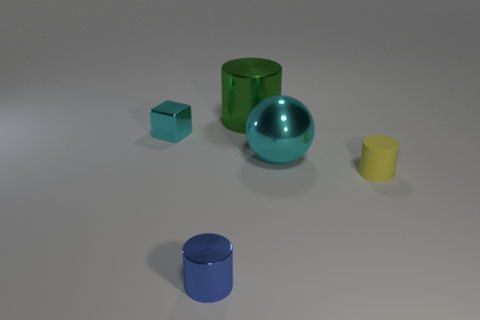There is a large object that is the same material as the large cylinder; what shape is it?
Offer a very short reply. Sphere. Is the number of cyan spheres to the left of the large cyan thing greater than the number of blue metallic cylinders?
Provide a short and direct response. No. How many tiny metal cubes have the same color as the big sphere?
Your answer should be very brief. 1. How many other things are the same color as the rubber cylinder?
Your answer should be compact. 0. Are there more metal objects than purple things?
Give a very brief answer. Yes. What is the material of the tiny yellow cylinder?
Offer a very short reply. Rubber. There is a metallic cylinder that is in front of the matte cylinder; is it the same size as the shiny sphere?
Make the answer very short. No. What size is the cyan shiny object that is on the right side of the blue cylinder?
Provide a succinct answer. Large. Is there anything else that has the same material as the tiny yellow object?
Your response must be concise. No. What number of tiny green spheres are there?
Provide a short and direct response. 0. 